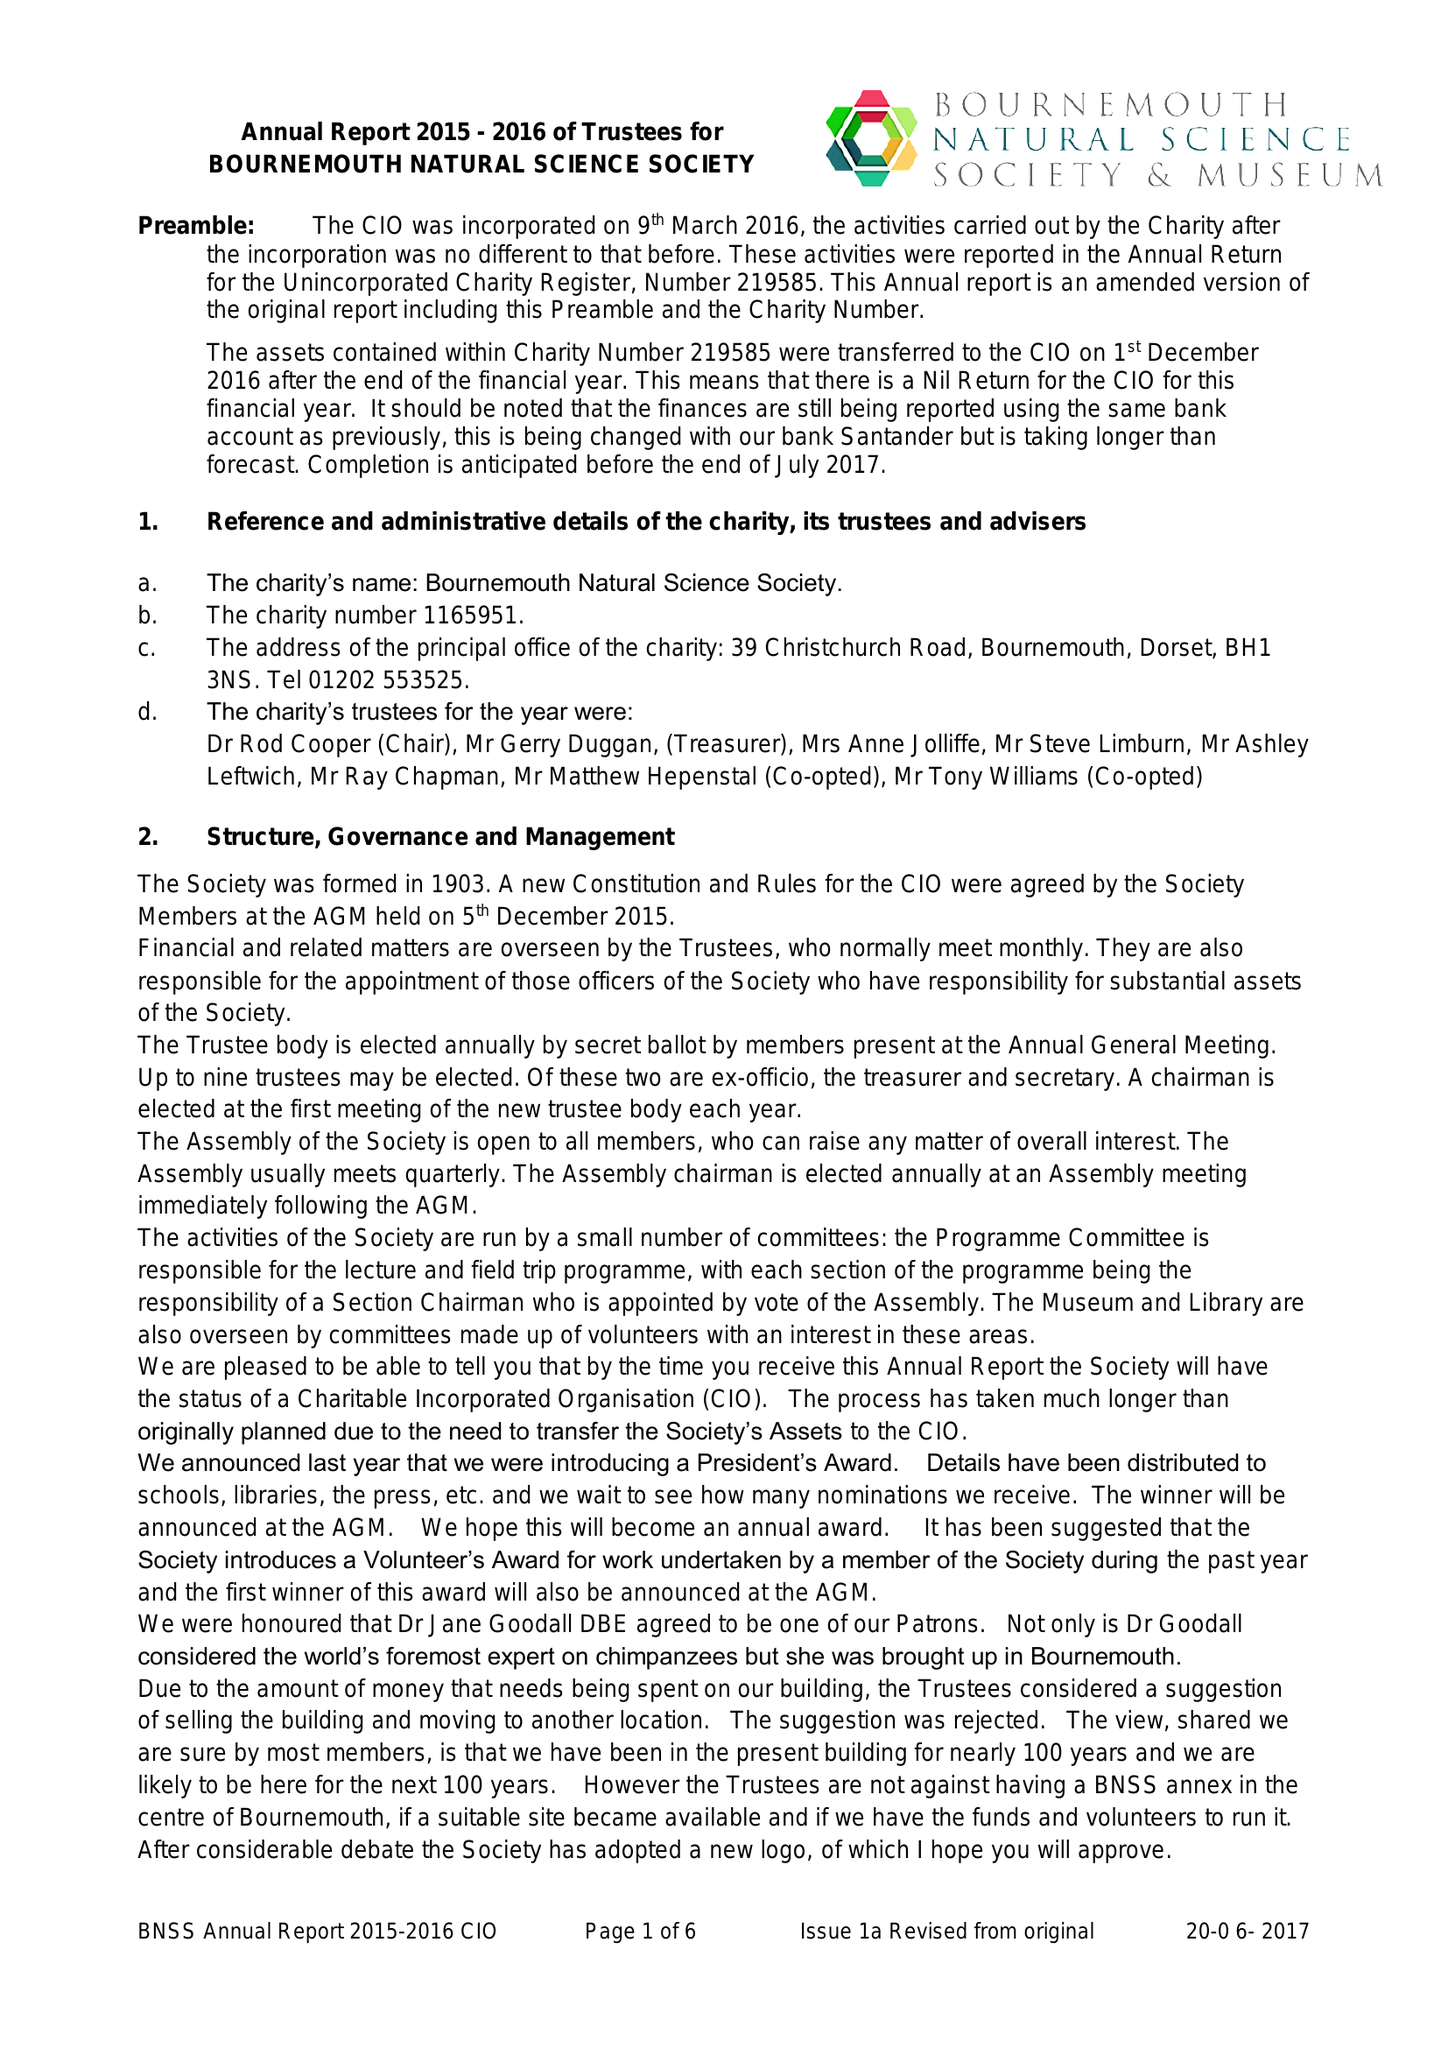What is the value for the income_annually_in_british_pounds?
Answer the question using a single word or phrase. None 